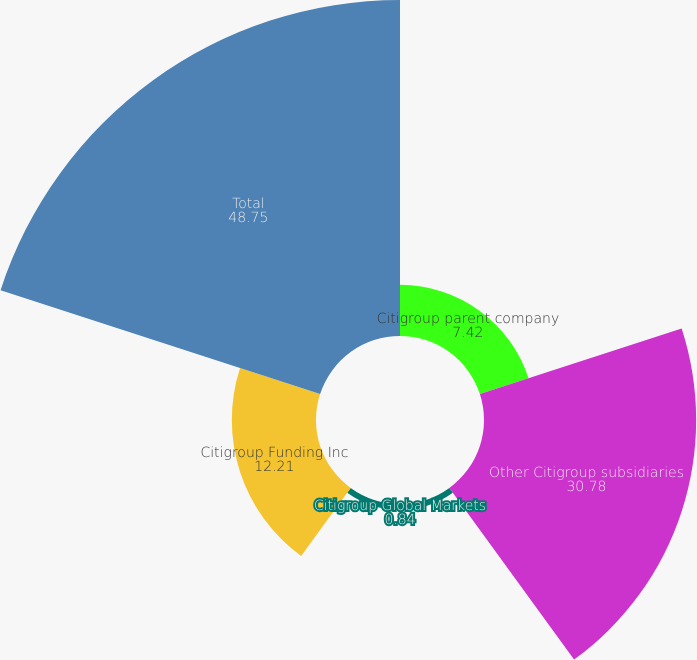<chart> <loc_0><loc_0><loc_500><loc_500><pie_chart><fcel>Citigroup parent company<fcel>Other Citigroup subsidiaries<fcel>Citigroup Global Markets<fcel>Citigroup Funding Inc<fcel>Total<nl><fcel>7.42%<fcel>30.78%<fcel>0.84%<fcel>12.21%<fcel>48.75%<nl></chart> 